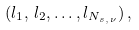<formula> <loc_0><loc_0><loc_500><loc_500>( l _ { 1 } , \, l _ { 2 } , \dots , l _ { N _ { s , \, \nu } } ) \, ,</formula> 